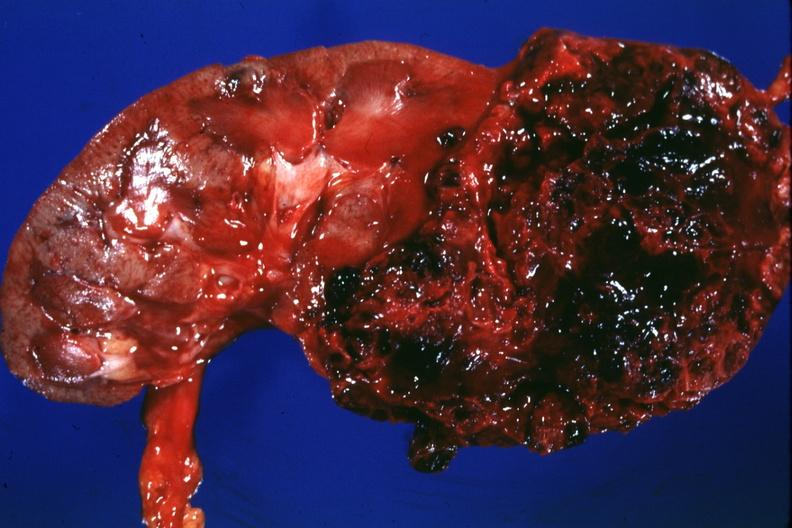s renal cell carcinoma present?
Answer the question using a single word or phrase. Yes 